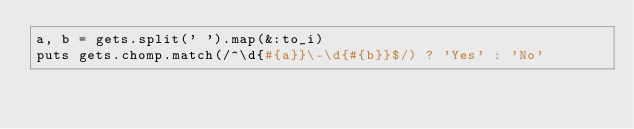<code> <loc_0><loc_0><loc_500><loc_500><_Ruby_>a, b = gets.split(' ').map(&:to_i)
puts gets.chomp.match(/^\d{#{a}}\-\d{#{b}}$/) ? 'Yes' : 'No'</code> 